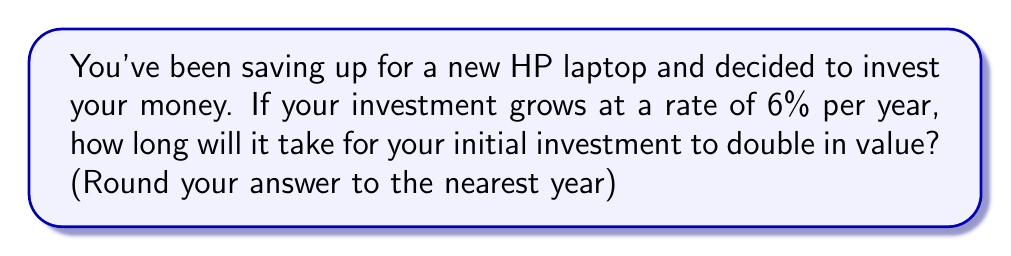Could you help me with this problem? Let's break this down step-by-step using the rule of 72, which is a simple way to estimate how long it takes for an investment to double:

1. The rule of 72 states that we can estimate the time it takes for an investment to double by dividing 72 by the annual growth rate (as a percentage).

2. In this case, our annual growth rate is 6%.

3. Let's apply the formula:
   
   $$ \text{Time to double} = \frac{72}{\text{Annual growth rate}} $$

4. Plugging in our values:
   
   $$ \text{Time to double} = \frac{72}{6} = 12 $$

5. The result is 12 years.

6. Since we're asked to round to the nearest year, our final answer is 12 years.

This method gives us a good approximation without using complex logarithmic calculations, which is perfect for a quick estimate when shopping for your new HP laptop!
Answer: 12 years 